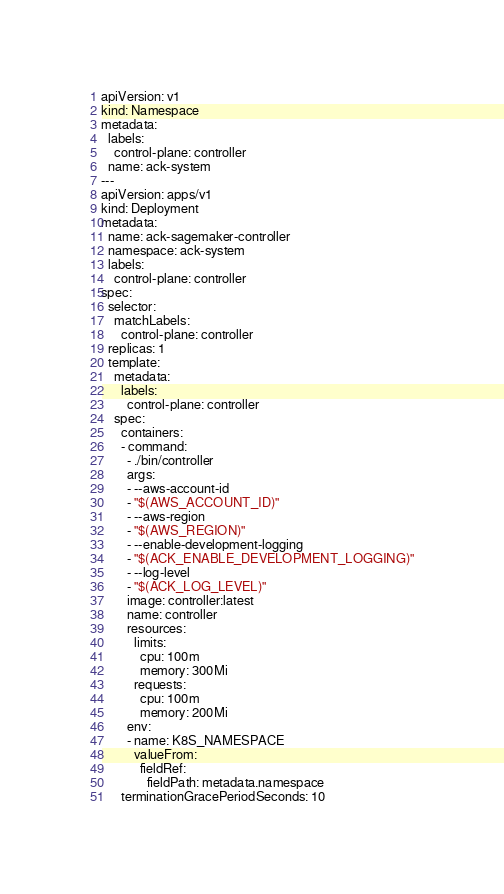Convert code to text. <code><loc_0><loc_0><loc_500><loc_500><_YAML_>apiVersion: v1
kind: Namespace
metadata:
  labels:
    control-plane: controller
  name: ack-system
---
apiVersion: apps/v1
kind: Deployment
metadata:
  name: ack-sagemaker-controller
  namespace: ack-system
  labels:
    control-plane: controller
spec:
  selector:
    matchLabels:
      control-plane: controller
  replicas: 1
  template:
    metadata:
      labels:
        control-plane: controller
    spec:
      containers:
      - command:
        - ./bin/controller
        args:
        - --aws-account-id
        - "$(AWS_ACCOUNT_ID)"
        - --aws-region
        - "$(AWS_REGION)"
        - --enable-development-logging
        - "$(ACK_ENABLE_DEVELOPMENT_LOGGING)"
        - --log-level
        - "$(ACK_LOG_LEVEL)"
        image: controller:latest
        name: controller
        resources:
          limits:
            cpu: 100m
            memory: 300Mi
          requests:
            cpu: 100m
            memory: 200Mi
        env:
        - name: K8S_NAMESPACE
          valueFrom:
            fieldRef:
              fieldPath: metadata.namespace
      terminationGracePeriodSeconds: 10
</code> 